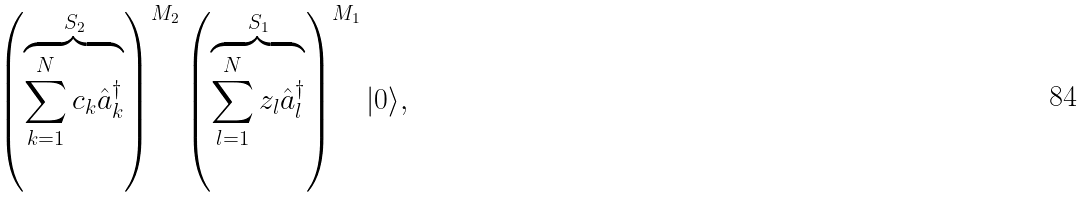Convert formula to latex. <formula><loc_0><loc_0><loc_500><loc_500>\left ( \overbrace { \sum _ { k = 1 } ^ { N } c _ { k } \hat { a } _ { k } ^ { \dagger } } ^ { S _ { 2 } } \right ) ^ { M _ { 2 } } \left ( \overbrace { \sum _ { l = 1 } ^ { N } z _ { l } \hat { a } _ { l } ^ { \dagger } } ^ { S _ { 1 } } \right ) ^ { M _ { 1 } } | 0 \rangle ,</formula> 